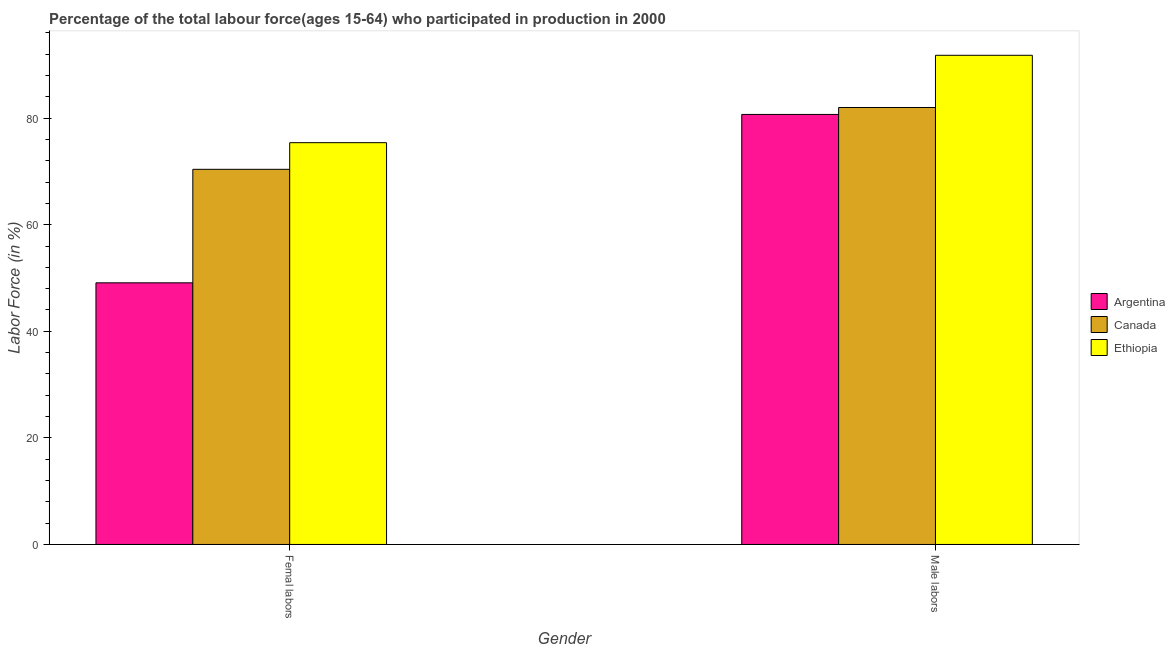How many different coloured bars are there?
Your response must be concise. 3. How many groups of bars are there?
Provide a succinct answer. 2. How many bars are there on the 1st tick from the right?
Your answer should be compact. 3. What is the label of the 2nd group of bars from the left?
Provide a succinct answer. Male labors. What is the percentage of female labor force in Ethiopia?
Provide a short and direct response. 75.4. Across all countries, what is the maximum percentage of male labour force?
Your response must be concise. 91.8. Across all countries, what is the minimum percentage of male labour force?
Offer a very short reply. 80.7. In which country was the percentage of male labour force maximum?
Provide a short and direct response. Ethiopia. What is the total percentage of female labor force in the graph?
Your response must be concise. 194.9. What is the difference between the percentage of female labor force in Argentina and that in Ethiopia?
Provide a succinct answer. -26.3. What is the difference between the percentage of male labour force in Argentina and the percentage of female labor force in Canada?
Keep it short and to the point. 10.3. What is the average percentage of male labour force per country?
Your answer should be compact. 84.83. What is the difference between the percentage of female labor force and percentage of male labour force in Ethiopia?
Ensure brevity in your answer.  -16.4. In how many countries, is the percentage of male labour force greater than 68 %?
Your answer should be very brief. 3. What is the ratio of the percentage of male labour force in Ethiopia to that in Argentina?
Ensure brevity in your answer.  1.14. Is the percentage of female labor force in Argentina less than that in Canada?
Provide a succinct answer. Yes. In how many countries, is the percentage of male labour force greater than the average percentage of male labour force taken over all countries?
Make the answer very short. 1. What does the 3rd bar from the right in Femal labors represents?
Provide a short and direct response. Argentina. Are all the bars in the graph horizontal?
Keep it short and to the point. No. Are the values on the major ticks of Y-axis written in scientific E-notation?
Give a very brief answer. No. Does the graph contain any zero values?
Offer a terse response. No. Where does the legend appear in the graph?
Your answer should be very brief. Center right. What is the title of the graph?
Your answer should be very brief. Percentage of the total labour force(ages 15-64) who participated in production in 2000. What is the label or title of the X-axis?
Provide a succinct answer. Gender. What is the label or title of the Y-axis?
Your answer should be very brief. Labor Force (in %). What is the Labor Force (in %) of Argentina in Femal labors?
Your response must be concise. 49.1. What is the Labor Force (in %) in Canada in Femal labors?
Your answer should be compact. 70.4. What is the Labor Force (in %) of Ethiopia in Femal labors?
Offer a very short reply. 75.4. What is the Labor Force (in %) in Argentina in Male labors?
Provide a succinct answer. 80.7. What is the Labor Force (in %) in Canada in Male labors?
Your answer should be very brief. 82. What is the Labor Force (in %) in Ethiopia in Male labors?
Keep it short and to the point. 91.8. Across all Gender, what is the maximum Labor Force (in %) of Argentina?
Make the answer very short. 80.7. Across all Gender, what is the maximum Labor Force (in %) in Ethiopia?
Your response must be concise. 91.8. Across all Gender, what is the minimum Labor Force (in %) in Argentina?
Give a very brief answer. 49.1. Across all Gender, what is the minimum Labor Force (in %) of Canada?
Make the answer very short. 70.4. Across all Gender, what is the minimum Labor Force (in %) of Ethiopia?
Provide a short and direct response. 75.4. What is the total Labor Force (in %) of Argentina in the graph?
Your answer should be very brief. 129.8. What is the total Labor Force (in %) in Canada in the graph?
Your response must be concise. 152.4. What is the total Labor Force (in %) in Ethiopia in the graph?
Provide a short and direct response. 167.2. What is the difference between the Labor Force (in %) of Argentina in Femal labors and that in Male labors?
Provide a succinct answer. -31.6. What is the difference between the Labor Force (in %) in Ethiopia in Femal labors and that in Male labors?
Your answer should be compact. -16.4. What is the difference between the Labor Force (in %) of Argentina in Femal labors and the Labor Force (in %) of Canada in Male labors?
Keep it short and to the point. -32.9. What is the difference between the Labor Force (in %) in Argentina in Femal labors and the Labor Force (in %) in Ethiopia in Male labors?
Make the answer very short. -42.7. What is the difference between the Labor Force (in %) of Canada in Femal labors and the Labor Force (in %) of Ethiopia in Male labors?
Keep it short and to the point. -21.4. What is the average Labor Force (in %) of Argentina per Gender?
Offer a terse response. 64.9. What is the average Labor Force (in %) of Canada per Gender?
Provide a short and direct response. 76.2. What is the average Labor Force (in %) of Ethiopia per Gender?
Your answer should be compact. 83.6. What is the difference between the Labor Force (in %) of Argentina and Labor Force (in %) of Canada in Femal labors?
Give a very brief answer. -21.3. What is the difference between the Labor Force (in %) of Argentina and Labor Force (in %) of Ethiopia in Femal labors?
Your response must be concise. -26.3. What is the difference between the Labor Force (in %) in Argentina and Labor Force (in %) in Canada in Male labors?
Offer a terse response. -1.3. What is the difference between the Labor Force (in %) in Canada and Labor Force (in %) in Ethiopia in Male labors?
Offer a very short reply. -9.8. What is the ratio of the Labor Force (in %) of Argentina in Femal labors to that in Male labors?
Offer a very short reply. 0.61. What is the ratio of the Labor Force (in %) in Canada in Femal labors to that in Male labors?
Provide a succinct answer. 0.86. What is the ratio of the Labor Force (in %) in Ethiopia in Femal labors to that in Male labors?
Make the answer very short. 0.82. What is the difference between the highest and the second highest Labor Force (in %) of Argentina?
Your answer should be very brief. 31.6. What is the difference between the highest and the second highest Labor Force (in %) of Ethiopia?
Make the answer very short. 16.4. What is the difference between the highest and the lowest Labor Force (in %) of Argentina?
Offer a very short reply. 31.6. What is the difference between the highest and the lowest Labor Force (in %) of Ethiopia?
Give a very brief answer. 16.4. 